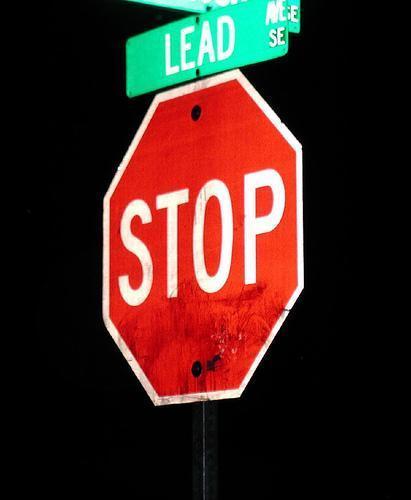How many stop signs are there?
Give a very brief answer. 1. 